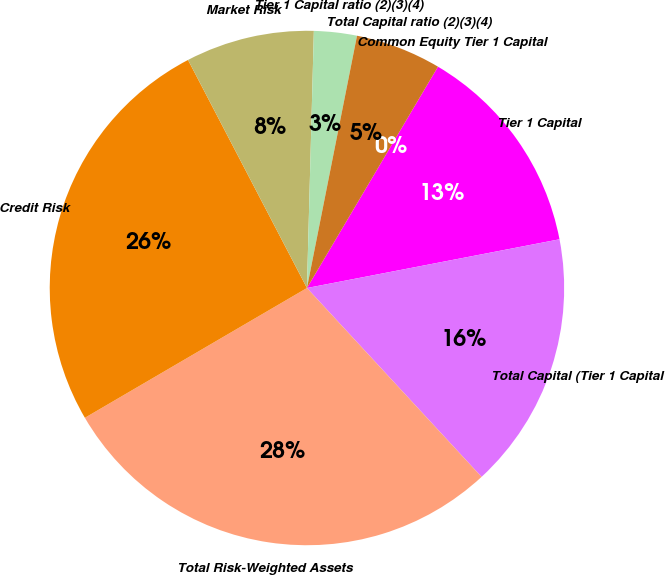Convert chart. <chart><loc_0><loc_0><loc_500><loc_500><pie_chart><fcel>Common Equity Tier 1 Capital<fcel>Tier 1 Capital<fcel>Total Capital (Tier 1 Capital<fcel>Total Risk-Weighted Assets<fcel>Credit Risk<fcel>Market Risk<fcel>Tier 1 Capital ratio (2)(3)(4)<fcel>Total Capital ratio (2)(3)(4)<nl><fcel>0.0%<fcel>13.46%<fcel>16.16%<fcel>28.46%<fcel>25.77%<fcel>8.08%<fcel>2.69%<fcel>5.39%<nl></chart> 